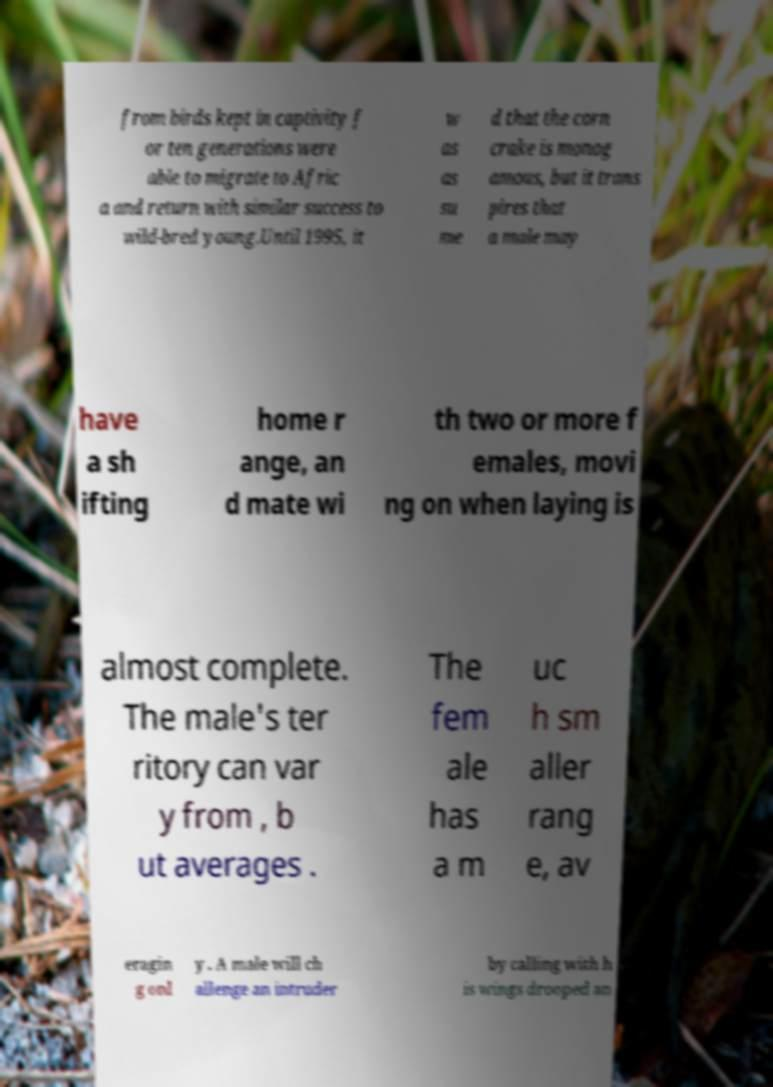Can you accurately transcribe the text from the provided image for me? from birds kept in captivity f or ten generations were able to migrate to Afric a and return with similar success to wild-bred young.Until 1995, it w as as su me d that the corn crake is monog amous, but it trans pires that a male may have a sh ifting home r ange, an d mate wi th two or more f emales, movi ng on when laying is almost complete. The male's ter ritory can var y from , b ut averages . The fem ale has a m uc h sm aller rang e, av eragin g onl y . A male will ch allenge an intruder by calling with h is wings drooped an 